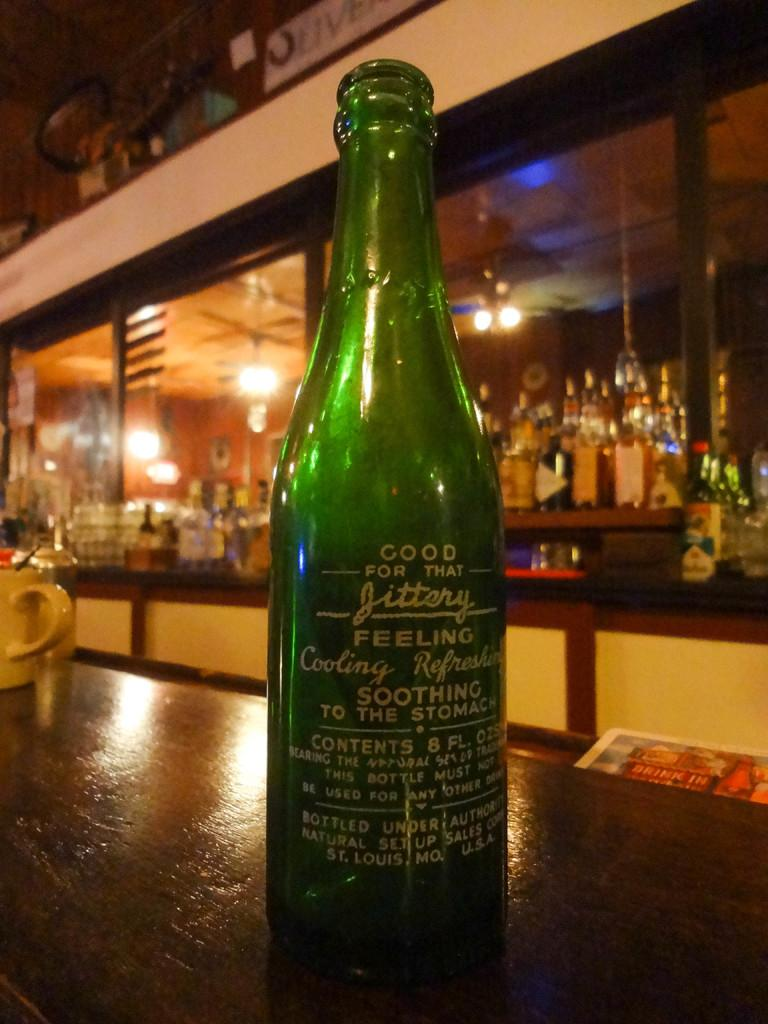Provide a one-sentence caption for the provided image. A green bottle that advertisises that it is "good for that jittery feeling". 